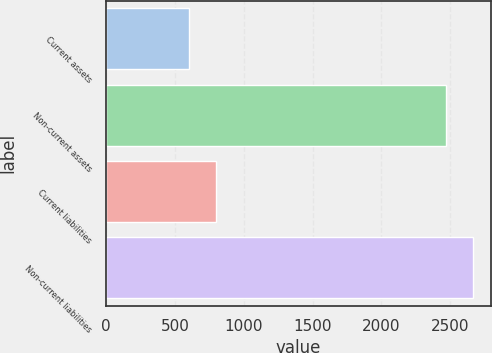<chart> <loc_0><loc_0><loc_500><loc_500><bar_chart><fcel>Current assets<fcel>Non-current assets<fcel>Current liabilities<fcel>Non-current liabilities<nl><fcel>605<fcel>2470<fcel>797.9<fcel>2662.9<nl></chart> 